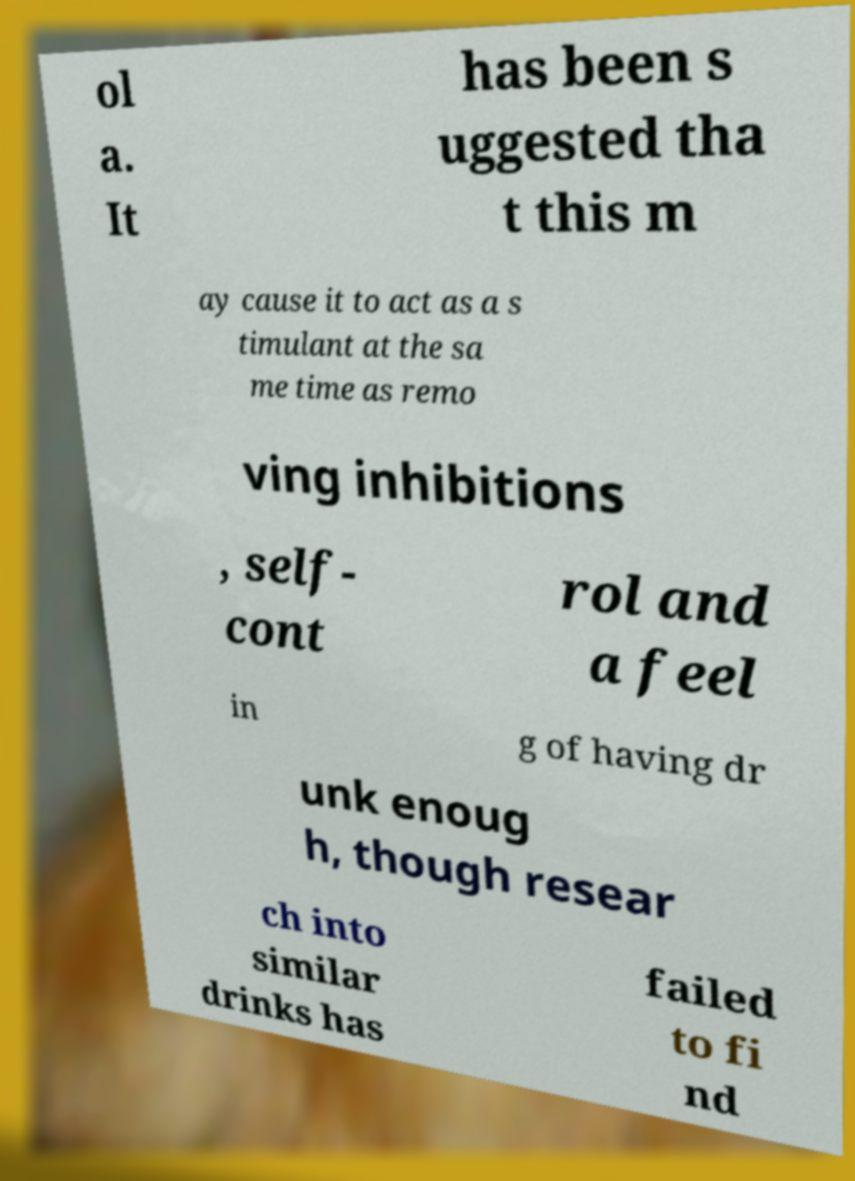What messages or text are displayed in this image? I need them in a readable, typed format. ol a. It has been s uggested tha t this m ay cause it to act as a s timulant at the sa me time as remo ving inhibitions , self- cont rol and a feel in g of having dr unk enoug h, though resear ch into similar drinks has failed to fi nd 